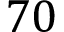<formula> <loc_0><loc_0><loc_500><loc_500>7 0</formula> 